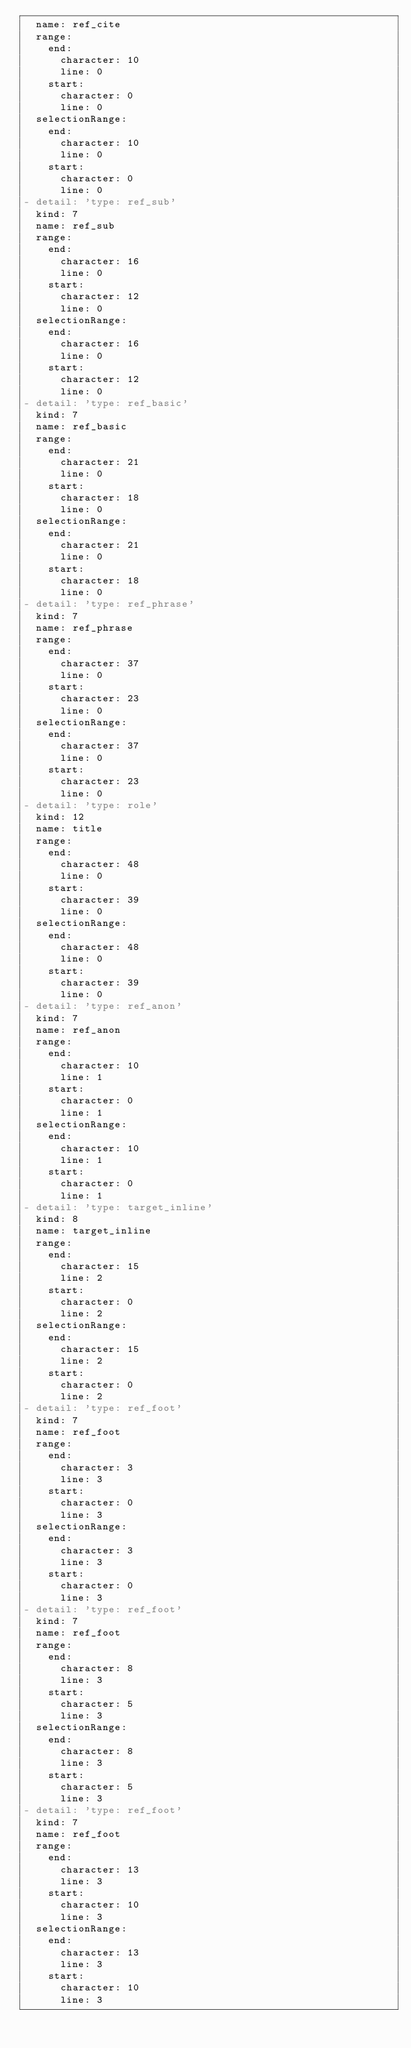Convert code to text. <code><loc_0><loc_0><loc_500><loc_500><_YAML_>  name: ref_cite
  range:
    end:
      character: 10
      line: 0
    start:
      character: 0
      line: 0
  selectionRange:
    end:
      character: 10
      line: 0
    start:
      character: 0
      line: 0
- detail: 'type: ref_sub'
  kind: 7
  name: ref_sub
  range:
    end:
      character: 16
      line: 0
    start:
      character: 12
      line: 0
  selectionRange:
    end:
      character: 16
      line: 0
    start:
      character: 12
      line: 0
- detail: 'type: ref_basic'
  kind: 7
  name: ref_basic
  range:
    end:
      character: 21
      line: 0
    start:
      character: 18
      line: 0
  selectionRange:
    end:
      character: 21
      line: 0
    start:
      character: 18
      line: 0
- detail: 'type: ref_phrase'
  kind: 7
  name: ref_phrase
  range:
    end:
      character: 37
      line: 0
    start:
      character: 23
      line: 0
  selectionRange:
    end:
      character: 37
      line: 0
    start:
      character: 23
      line: 0
- detail: 'type: role'
  kind: 12
  name: title
  range:
    end:
      character: 48
      line: 0
    start:
      character: 39
      line: 0
  selectionRange:
    end:
      character: 48
      line: 0
    start:
      character: 39
      line: 0
- detail: 'type: ref_anon'
  kind: 7
  name: ref_anon
  range:
    end:
      character: 10
      line: 1
    start:
      character: 0
      line: 1
  selectionRange:
    end:
      character: 10
      line: 1
    start:
      character: 0
      line: 1
- detail: 'type: target_inline'
  kind: 8
  name: target_inline
  range:
    end:
      character: 15
      line: 2
    start:
      character: 0
      line: 2
  selectionRange:
    end:
      character: 15
      line: 2
    start:
      character: 0
      line: 2
- detail: 'type: ref_foot'
  kind: 7
  name: ref_foot
  range:
    end:
      character: 3
      line: 3
    start:
      character: 0
      line: 3
  selectionRange:
    end:
      character: 3
      line: 3
    start:
      character: 0
      line: 3
- detail: 'type: ref_foot'
  kind: 7
  name: ref_foot
  range:
    end:
      character: 8
      line: 3
    start:
      character: 5
      line: 3
  selectionRange:
    end:
      character: 8
      line: 3
    start:
      character: 5
      line: 3
- detail: 'type: ref_foot'
  kind: 7
  name: ref_foot
  range:
    end:
      character: 13
      line: 3
    start:
      character: 10
      line: 3
  selectionRange:
    end:
      character: 13
      line: 3
    start:
      character: 10
      line: 3
</code> 